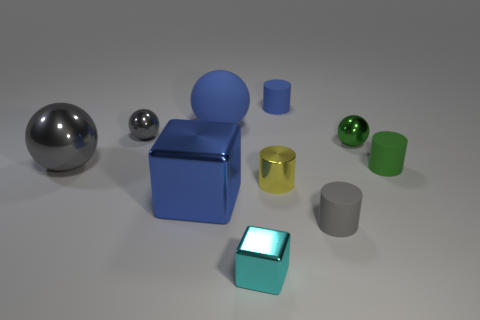What is the material of the tiny ball that is the same color as the large metal sphere?
Your answer should be very brief. Metal. Do the small ball right of the tiny cube and the tiny cylinder that is behind the small gray shiny thing have the same material?
Your answer should be compact. No. Are any tiny balls visible?
Your response must be concise. Yes. Is the number of blue matte cylinders that are to the left of the small gray metallic ball greater than the number of small rubber cylinders that are right of the tiny blue rubber cylinder?
Your response must be concise. No. What material is the small blue thing that is the same shape as the small gray rubber object?
Offer a very short reply. Rubber. Is there any other thing that is the same size as the yellow shiny cylinder?
Provide a short and direct response. Yes. Is the color of the tiny cylinder behind the big shiny sphere the same as the matte cylinder to the right of the green metal ball?
Offer a terse response. No. What shape is the green rubber object?
Provide a short and direct response. Cylinder. Is the number of tiny gray shiny balls that are on the right side of the small green metallic object greater than the number of small green objects?
Your answer should be very brief. No. The blue rubber thing left of the cyan cube has what shape?
Give a very brief answer. Sphere. 